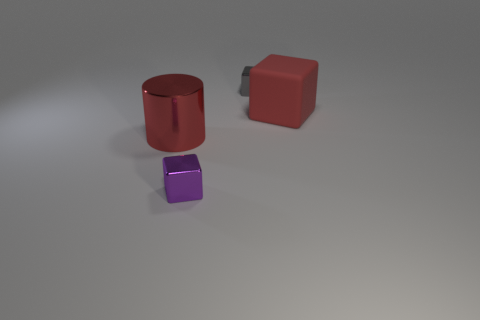Is there any other thing that is made of the same material as the large red block?
Ensure brevity in your answer.  No. What shape is the object that is the same color as the large cube?
Keep it short and to the point. Cylinder. How many red metal objects are the same size as the rubber block?
Provide a succinct answer. 1. Is the number of red matte objects that are to the left of the red metallic cylinder less than the number of big blue shiny cubes?
Provide a short and direct response. No. How many red shiny cylinders are in front of the tiny gray object?
Provide a short and direct response. 1. What is the size of the metallic thing that is behind the large object that is in front of the red object that is behind the red cylinder?
Offer a terse response. Small. Does the gray thing have the same shape as the small object that is in front of the large red shiny cylinder?
Provide a short and direct response. Yes. The gray block that is made of the same material as the purple thing is what size?
Provide a succinct answer. Small. Is there any other thing that has the same color as the big cube?
Offer a terse response. Yes. The small thing in front of the small metal thing right of the small metallic block in front of the tiny gray object is made of what material?
Offer a very short reply. Metal. 